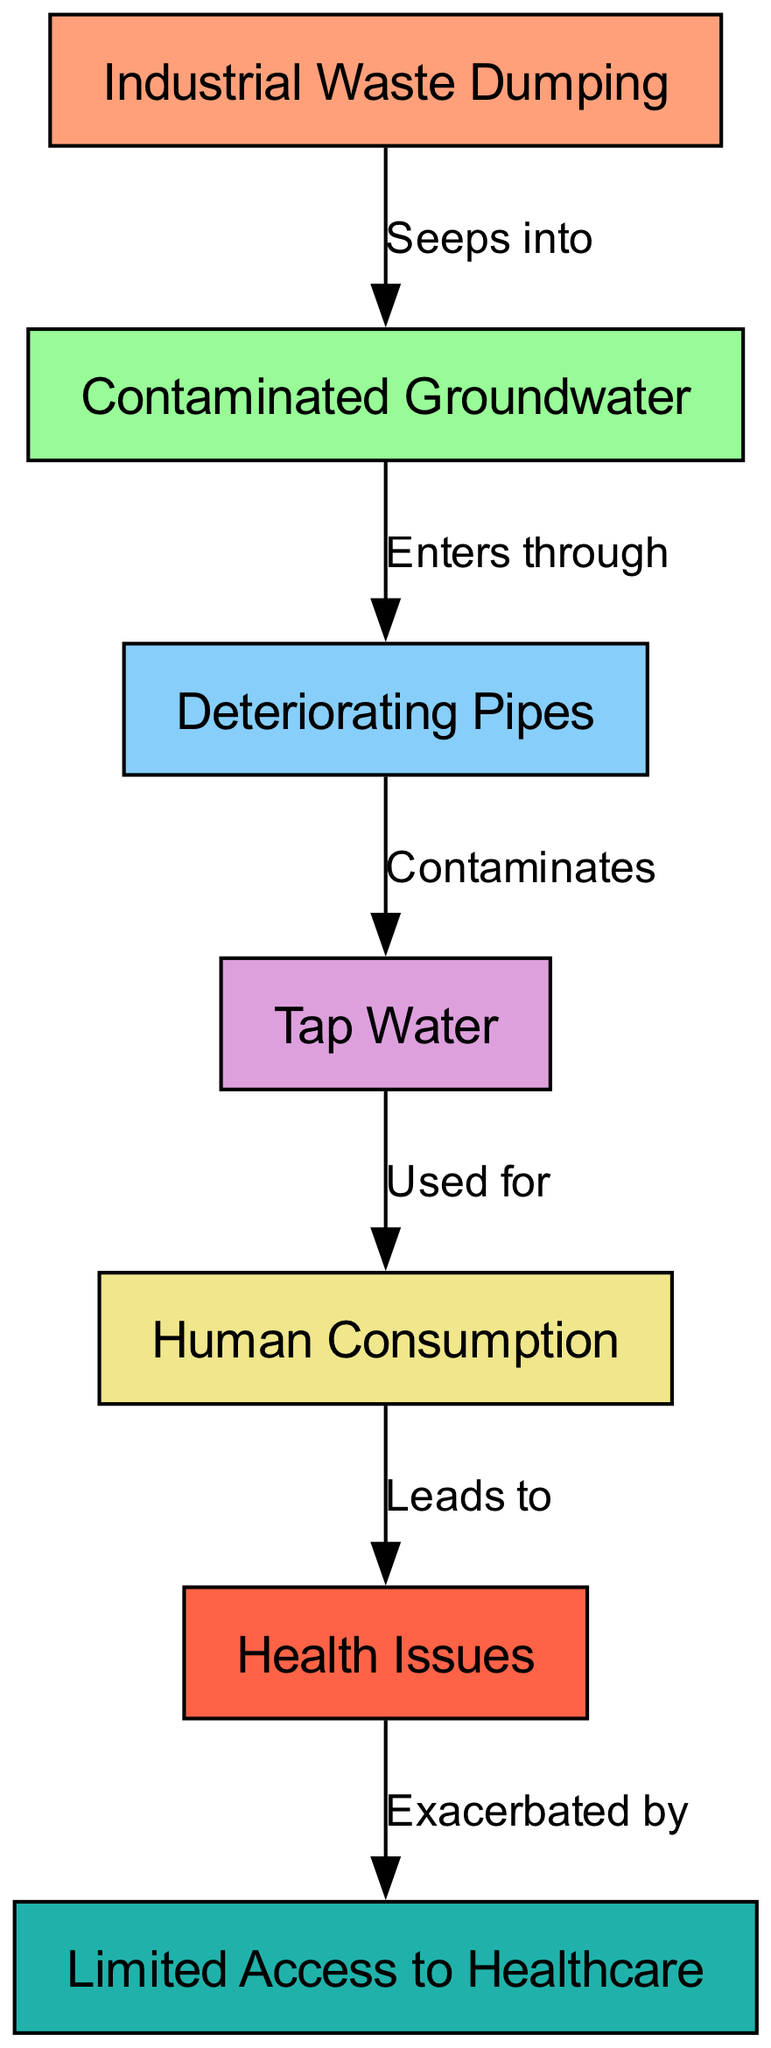What is the first node in the cycle? The first node in the cycle is identified as "Industrial Waste Dumping," which is the starting point that leads to the subsequent nodes.
Answer: Industrial Waste Dumping How many nodes are in the diagram? The diagram contains a total of 7 distinct nodes, each representing a crucial step or component in the life cycle of a pollutant.
Answer: 7 Which node leads to "Contaminated Groundwater"? The node "Industrial Waste Dumping" leads to the "Contaminated Groundwater." This relationship shows how the pollutant starts its cycle by seeping into groundwater.
Answer: Industrial Waste Dumping What does "Deteriorating Pipes" contaminate? "Deteriorating Pipes" contaminates "Tap Water," indicating that the deterioration of infrastructure directly affects water quality.
Answer: Tap Water What health issue is exacerbated by limited access to healthcare? The health issue referred to is "Health Issues," which is worsened due to the limited access to healthcare available.
Answer: Health Issues What leads to health issues? "Human Consumption" leads to health issues, as the act of consuming contaminated water results in negative health outcomes.
Answer: Human Consumption From which node does the final consequence of health issues arise? The final consequence of health issues arises from the node "Human Consumption," indicating that the cycle culminates in health problems following consumption.
Answer: Human Consumption How many edges are in the diagram? The diagram features 6 edges, representing the relationships between the nodes and the direction of the pollutant's cycle.
Answer: 6 What relationship exists between "Contaminated Groundwater" and "Deteriorating Pipes"? The relationship is that "Contaminated Groundwater" enters through "Deteriorating Pipes," which highlights a pathway for pollutants to contaminate water systems.
Answer: Enters through 